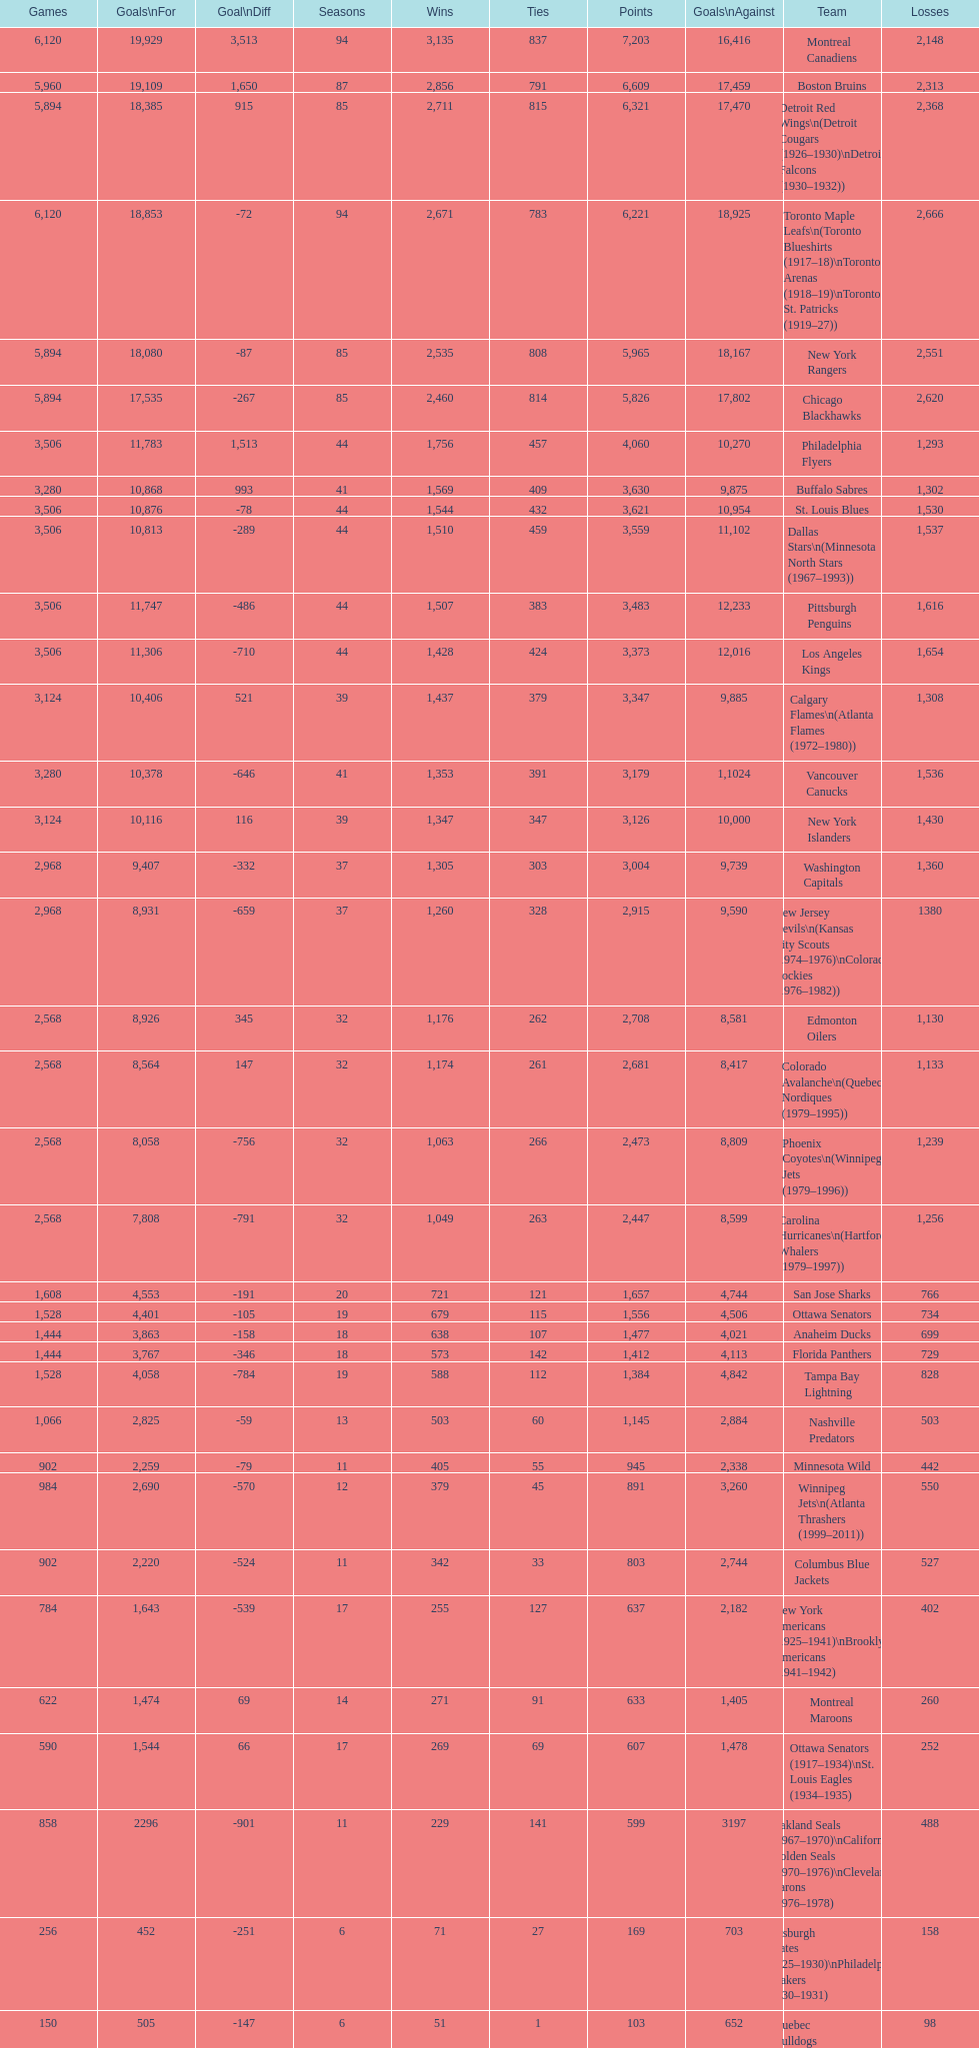Parse the table in full. {'header': ['Games', 'Goals\\nFor', 'Goal\\nDiff', 'Seasons', 'Wins', 'Ties', 'Points', 'Goals\\nAgainst', 'Team', 'Losses'], 'rows': [['6,120', '19,929', '3,513', '94', '3,135', '837', '7,203', '16,416', 'Montreal Canadiens', '2,148'], ['5,960', '19,109', '1,650', '87', '2,856', '791', '6,609', '17,459', 'Boston Bruins', '2,313'], ['5,894', '18,385', '915', '85', '2,711', '815', '6,321', '17,470', 'Detroit Red Wings\\n(Detroit Cougars (1926–1930)\\nDetroit Falcons (1930–1932))', '2,368'], ['6,120', '18,853', '-72', '94', '2,671', '783', '6,221', '18,925', 'Toronto Maple Leafs\\n(Toronto Blueshirts (1917–18)\\nToronto Arenas (1918–19)\\nToronto St. Patricks (1919–27))', '2,666'], ['5,894', '18,080', '-87', '85', '2,535', '808', '5,965', '18,167', 'New York Rangers', '2,551'], ['5,894', '17,535', '-267', '85', '2,460', '814', '5,826', '17,802', 'Chicago Blackhawks', '2,620'], ['3,506', '11,783', '1,513', '44', '1,756', '457', '4,060', '10,270', 'Philadelphia Flyers', '1,293'], ['3,280', '10,868', '993', '41', '1,569', '409', '3,630', '9,875', 'Buffalo Sabres', '1,302'], ['3,506', '10,876', '-78', '44', '1,544', '432', '3,621', '10,954', 'St. Louis Blues', '1,530'], ['3,506', '10,813', '-289', '44', '1,510', '459', '3,559', '11,102', 'Dallas Stars\\n(Minnesota North Stars (1967–1993))', '1,537'], ['3,506', '11,747', '-486', '44', '1,507', '383', '3,483', '12,233', 'Pittsburgh Penguins', '1,616'], ['3,506', '11,306', '-710', '44', '1,428', '424', '3,373', '12,016', 'Los Angeles Kings', '1,654'], ['3,124', '10,406', '521', '39', '1,437', '379', '3,347', '9,885', 'Calgary Flames\\n(Atlanta Flames (1972–1980))', '1,308'], ['3,280', '10,378', '-646', '41', '1,353', '391', '3,179', '1,1024', 'Vancouver Canucks', '1,536'], ['3,124', '10,116', '116', '39', '1,347', '347', '3,126', '10,000', 'New York Islanders', '1,430'], ['2,968', '9,407', '-332', '37', '1,305', '303', '3,004', '9,739', 'Washington Capitals', '1,360'], ['2,968', '8,931', '-659', '37', '1,260', '328', '2,915', '9,590', 'New Jersey Devils\\n(Kansas City Scouts (1974–1976)\\nColorado Rockies (1976–1982))', '1380'], ['2,568', '8,926', '345', '32', '1,176', '262', '2,708', '8,581', 'Edmonton Oilers', '1,130'], ['2,568', '8,564', '147', '32', '1,174', '261', '2,681', '8,417', 'Colorado Avalanche\\n(Quebec Nordiques (1979–1995))', '1,133'], ['2,568', '8,058', '-756', '32', '1,063', '266', '2,473', '8,809', 'Phoenix Coyotes\\n(Winnipeg Jets (1979–1996))', '1,239'], ['2,568', '7,808', '-791', '32', '1,049', '263', '2,447', '8,599', 'Carolina Hurricanes\\n(Hartford Whalers (1979–1997))', '1,256'], ['1,608', '4,553', '-191', '20', '721', '121', '1,657', '4,744', 'San Jose Sharks', '766'], ['1,528', '4,401', '-105', '19', '679', '115', '1,556', '4,506', 'Ottawa Senators', '734'], ['1,444', '3,863', '-158', '18', '638', '107', '1,477', '4,021', 'Anaheim Ducks', '699'], ['1,444', '3,767', '-346', '18', '573', '142', '1,412', '4,113', 'Florida Panthers', '729'], ['1,528', '4,058', '-784', '19', '588', '112', '1,384', '4,842', 'Tampa Bay Lightning', '828'], ['1,066', '2,825', '-59', '13', '503', '60', '1,145', '2,884', 'Nashville Predators', '503'], ['902', '2,259', '-79', '11', '405', '55', '945', '2,338', 'Minnesota Wild', '442'], ['984', '2,690', '-570', '12', '379', '45', '891', '3,260', 'Winnipeg Jets\\n(Atlanta Thrashers (1999–2011))', '550'], ['902', '2,220', '-524', '11', '342', '33', '803', '2,744', 'Columbus Blue Jackets', '527'], ['784', '1,643', '-539', '17', '255', '127', '637', '2,182', 'New York Americans (1925–1941)\\nBrooklyn Americans (1941–1942)', '402'], ['622', '1,474', '69', '14', '271', '91', '633', '1,405', 'Montreal Maroons', '260'], ['590', '1,544', '66', '17', '269', '69', '607', '1,478', 'Ottawa Senators (1917–1934)\\nSt. Louis Eagles (1934–1935)', '252'], ['858', '2296', '-901', '11', '229', '141', '599', '3197', 'Oakland Seals (1967–1970)\\nCalifornia Golden Seals (1970–1976)\\nCleveland Barons (1976–1978)', '488'], ['256', '452', '-251', '6', '71', '27', '169', '703', 'Pittsburgh Pirates (1925–1930)\\nPhiladelphia Quakers (1930–1931)', '158'], ['150', '505', '-147', '6', '51', '1', '103', '652', 'Quebec Bulldogs (1919–1920)\\nHamilton Tigers (1920–1925)', '98'], ['6', '17', '-18', '1', '1', '0', '2', '35', 'Montreal Wanderers', '5']]} Which team was last in terms of points up until this point? Montreal Wanderers. 